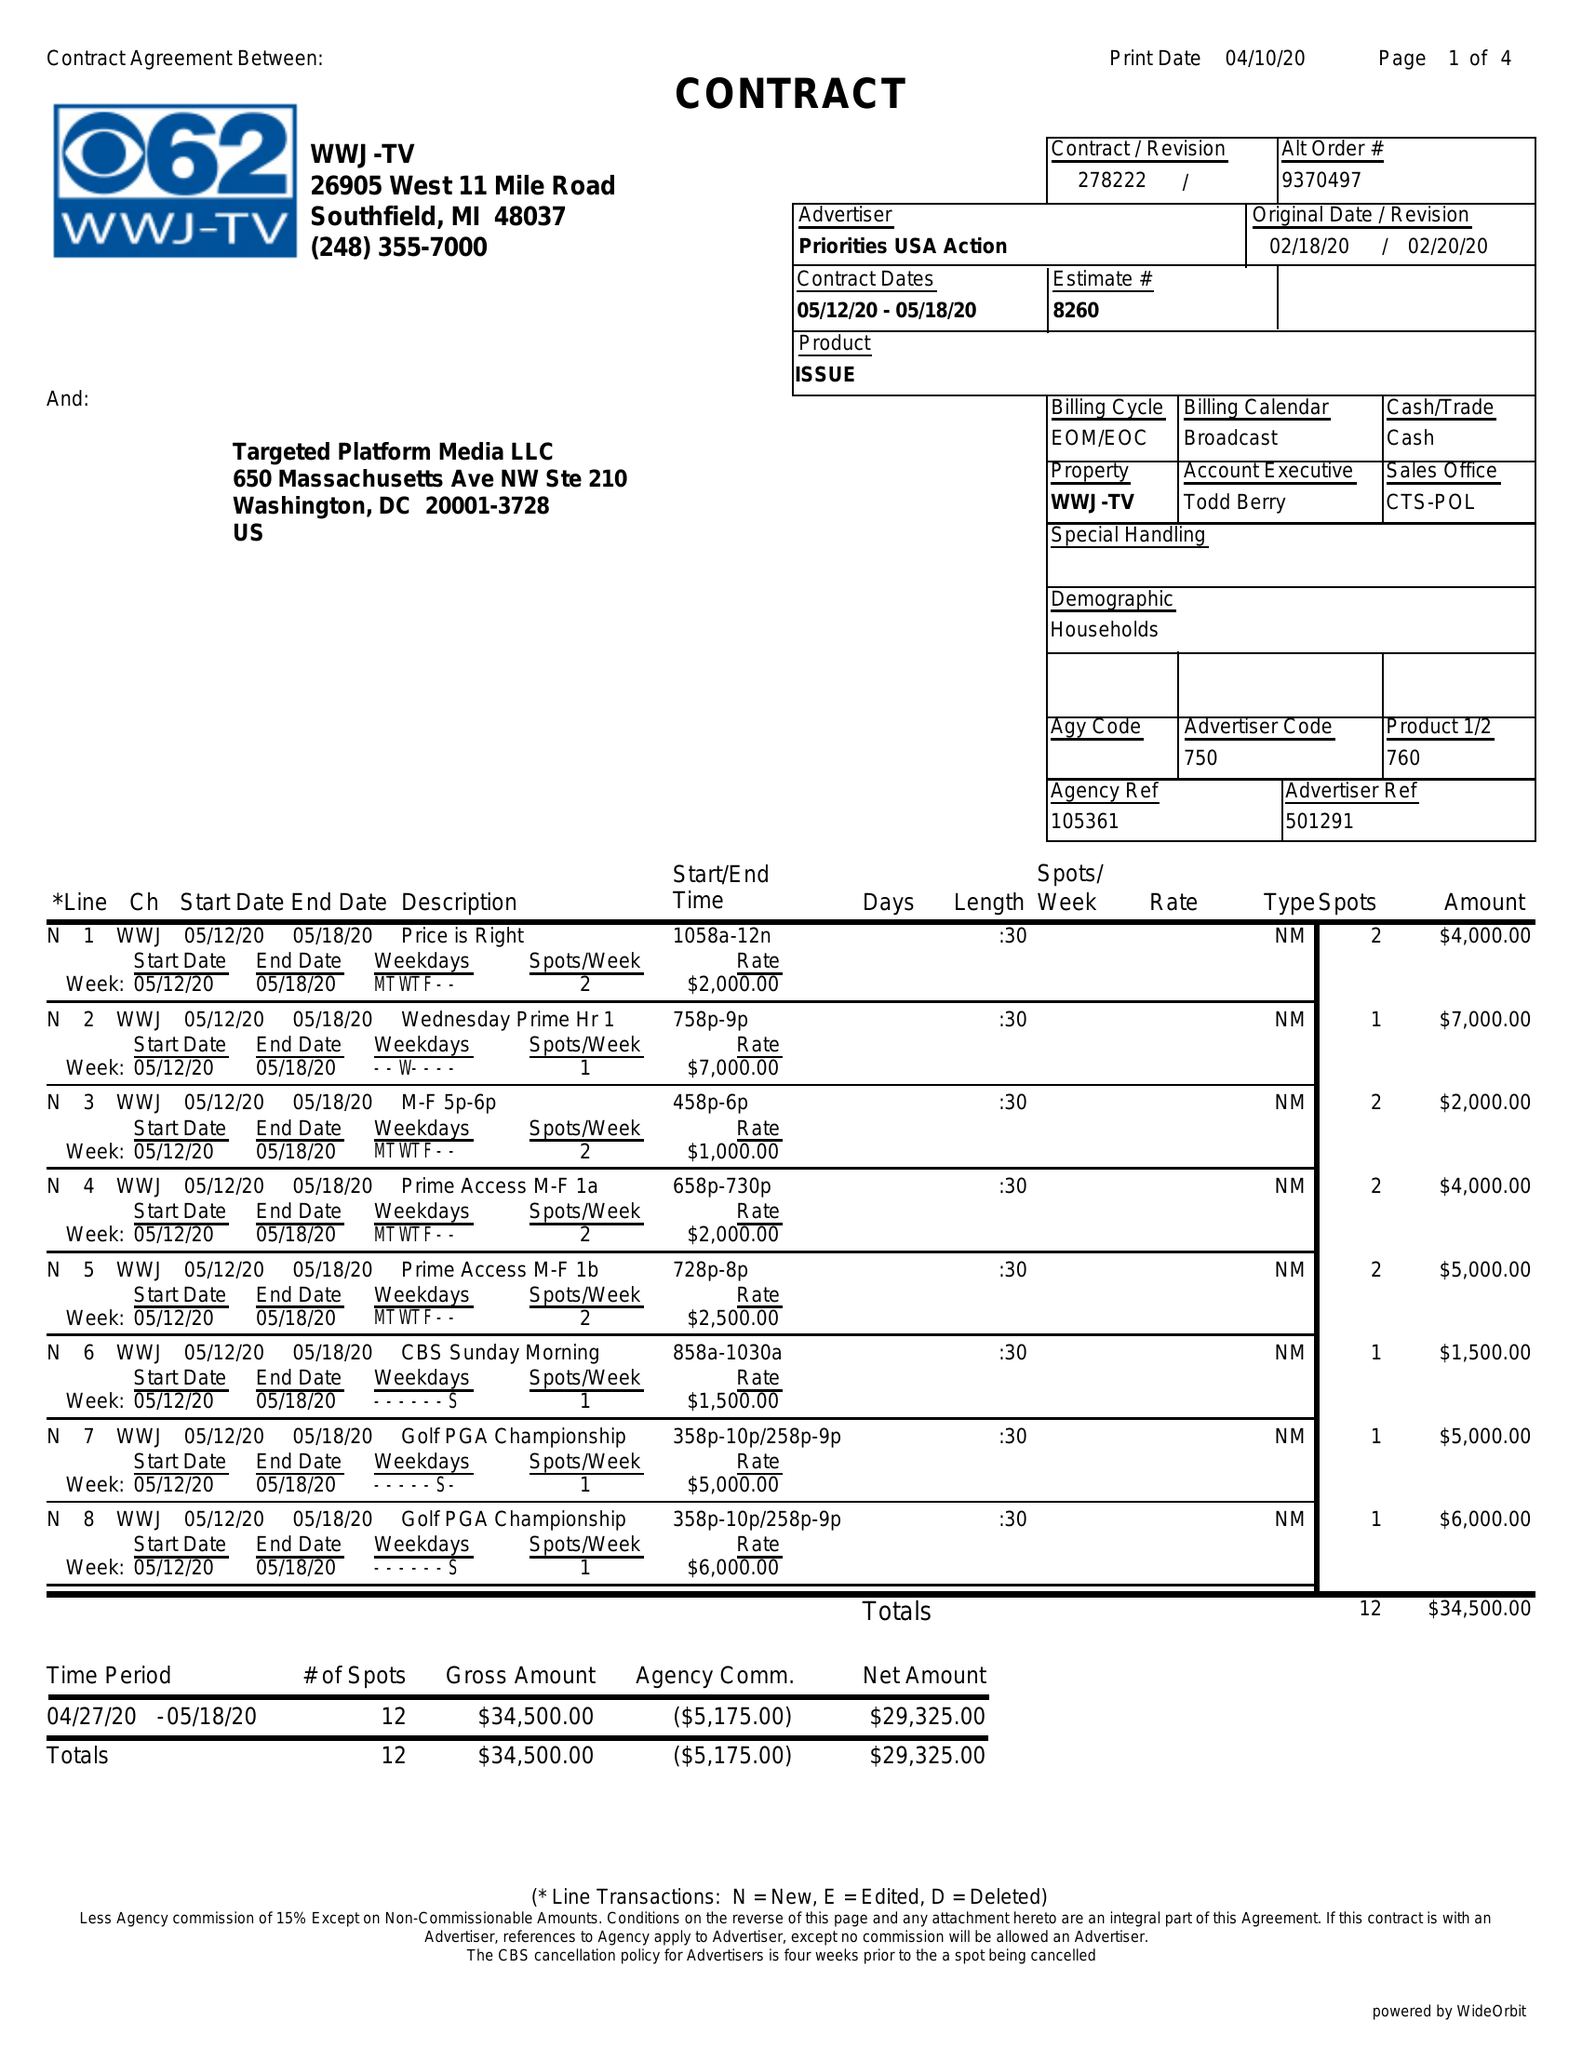What is the value for the gross_amount?
Answer the question using a single word or phrase. 34500.00 